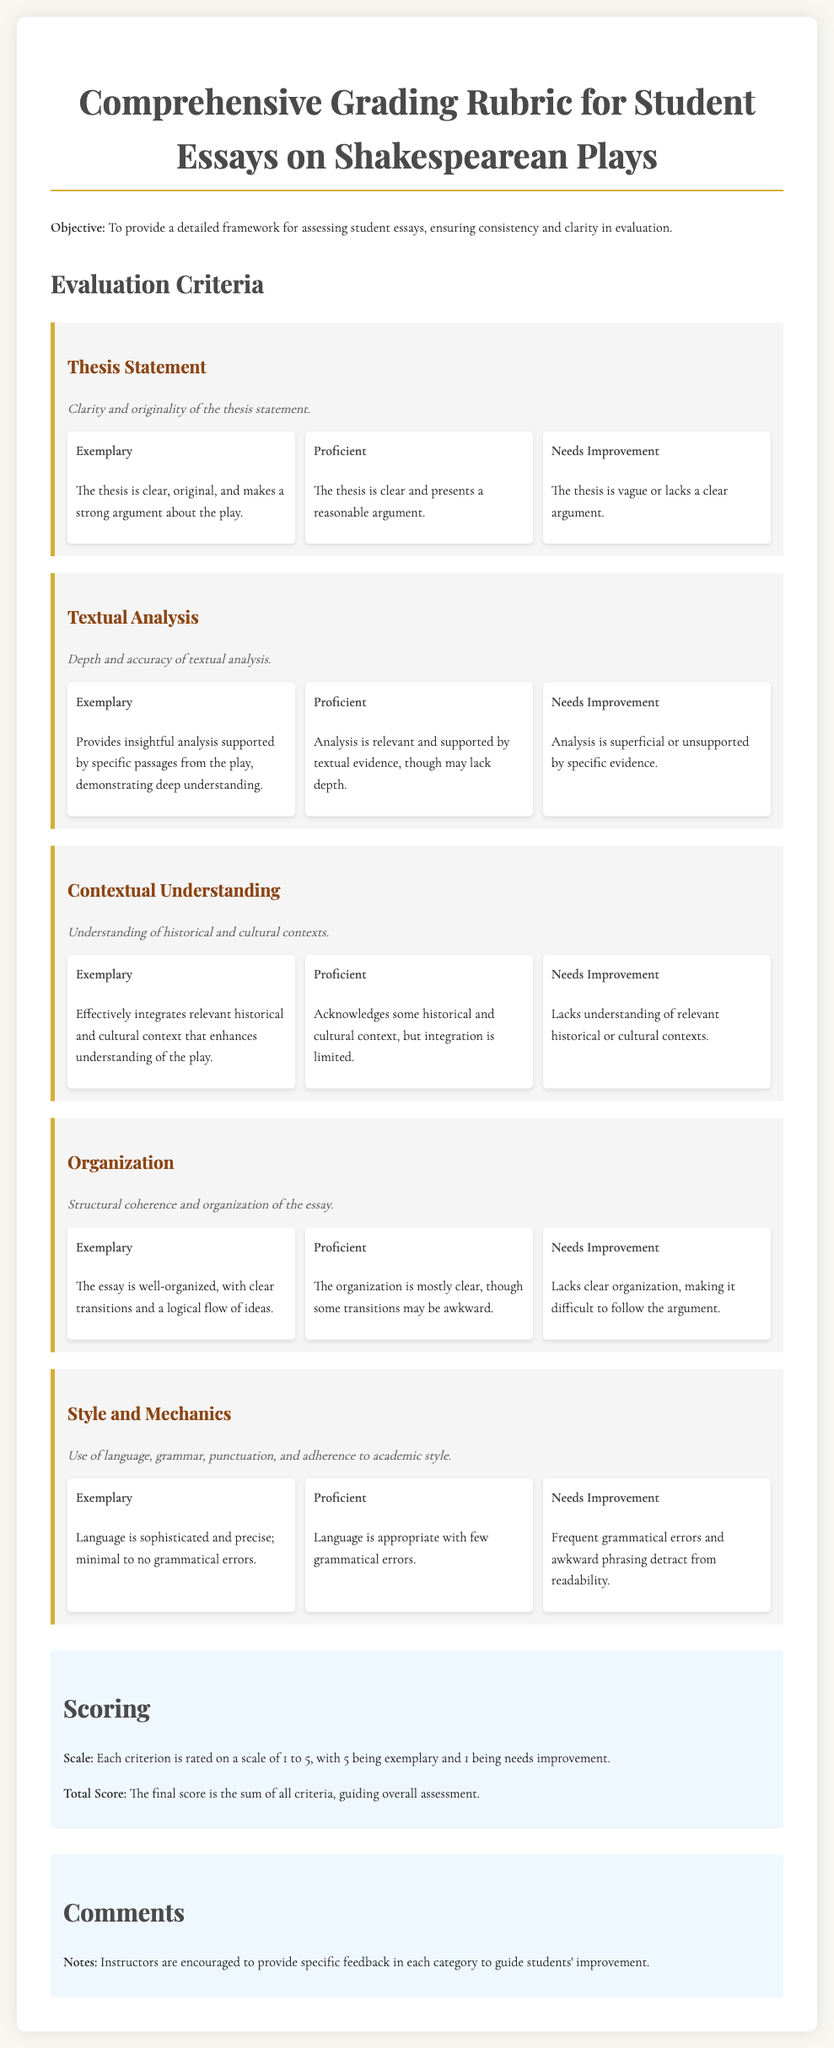What is the title of the document? The title is stated at the beginning of the document, introducing the main topic of assessment for essays.
Answer: Comprehensive Grading Rubric for Student Essays on Shakespearean Plays What are the three levels of ratings for the thesis statement? The document lists ratings that define the quality of the thesis statement in three categories.
Answer: Exemplary, Proficient, Needs Improvement What is the maximum score for each criterion? The scoring section specifies the rating scale applied to each criterion for essays.
Answer: 5 How is the overall score determined? The total score is explained as the sum of individual criterion scores in the scoring section.
Answer: The sum of all criteria What does the "Needs Improvement" rating indicate for style and mechanics? The document provides specific descriptions for each rating level, which include expected behaviors.
Answer: Frequent grammatical errors and awkward phrasing detract from readability What is the objective of the grading rubric? The opening paragraph describes the purpose of the document related to essay assessment.
Answer: To provide a detailed framework for assessing student essays What does the "Exemplary" rating for organizational structure signify? The rating explanation outlines the qualities that characterize top-level organization in essays.
Answer: The essay is well-organized, with clear transitions and a logical flow of ideas What does the rubric recommend for instructor comments? The conclusion in the comments section addresses feedback for students to improve.
Answer: Specific feedback in each category to guide students' improvement 